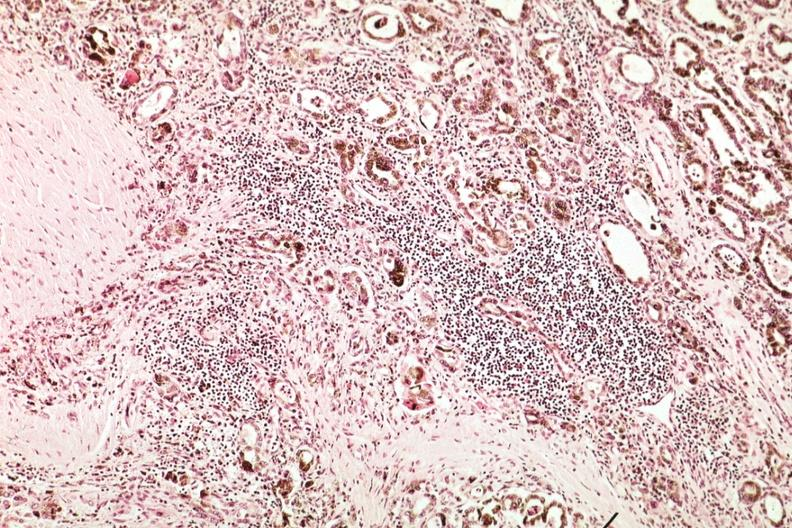what is present?
Answer the question using a single word or phrase. Thyroid 